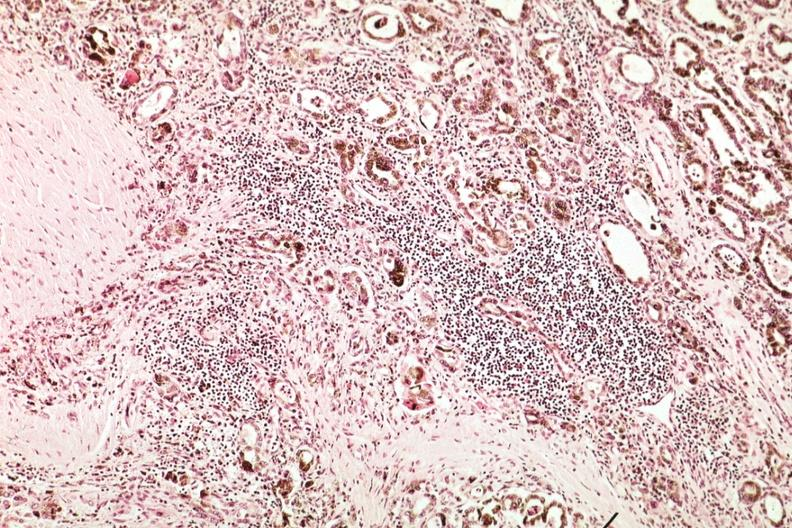what is present?
Answer the question using a single word or phrase. Thyroid 